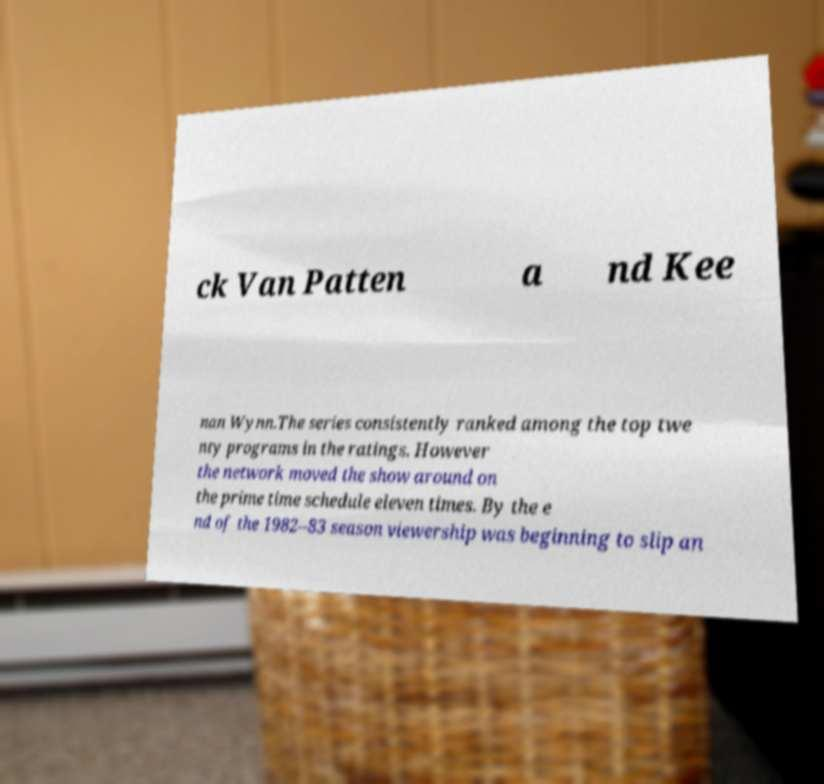Could you extract and type out the text from this image? ck Van Patten a nd Kee nan Wynn.The series consistently ranked among the top twe nty programs in the ratings. However the network moved the show around on the prime time schedule eleven times. By the e nd of the 1982–83 season viewership was beginning to slip an 